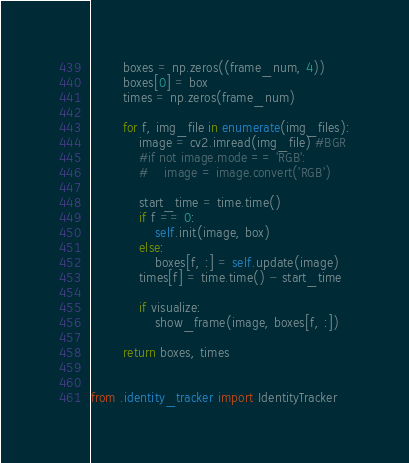<code> <loc_0><loc_0><loc_500><loc_500><_Python_>        boxes = np.zeros((frame_num, 4))
        boxes[0] = box
        times = np.zeros(frame_num)

        for f, img_file in enumerate(img_files):
            image = cv2.imread(img_file) #BGR
            #if not image.mode == 'RGB':
            #    image = image.convert('RGB')

            start_time = time.time()
            if f == 0:
                self.init(image, box)
            else:
                boxes[f, :] = self.update(image)
            times[f] = time.time() - start_time

            if visualize:
                show_frame(image, boxes[f, :])

        return boxes, times


from .identity_tracker import IdentityTracker
</code> 